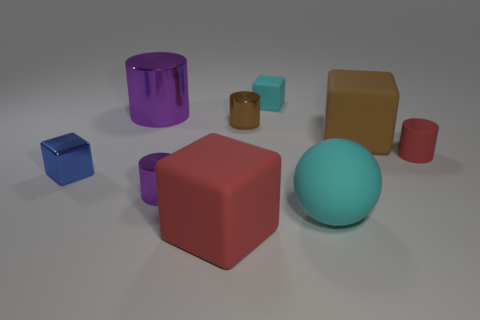Add 1 red matte cubes. How many objects exist? 10 Subtract 0 gray spheres. How many objects are left? 9 Subtract all blocks. How many objects are left? 5 Subtract all big green matte spheres. Subtract all large cyan spheres. How many objects are left? 8 Add 7 red objects. How many red objects are left? 9 Add 6 big matte spheres. How many big matte spheres exist? 7 